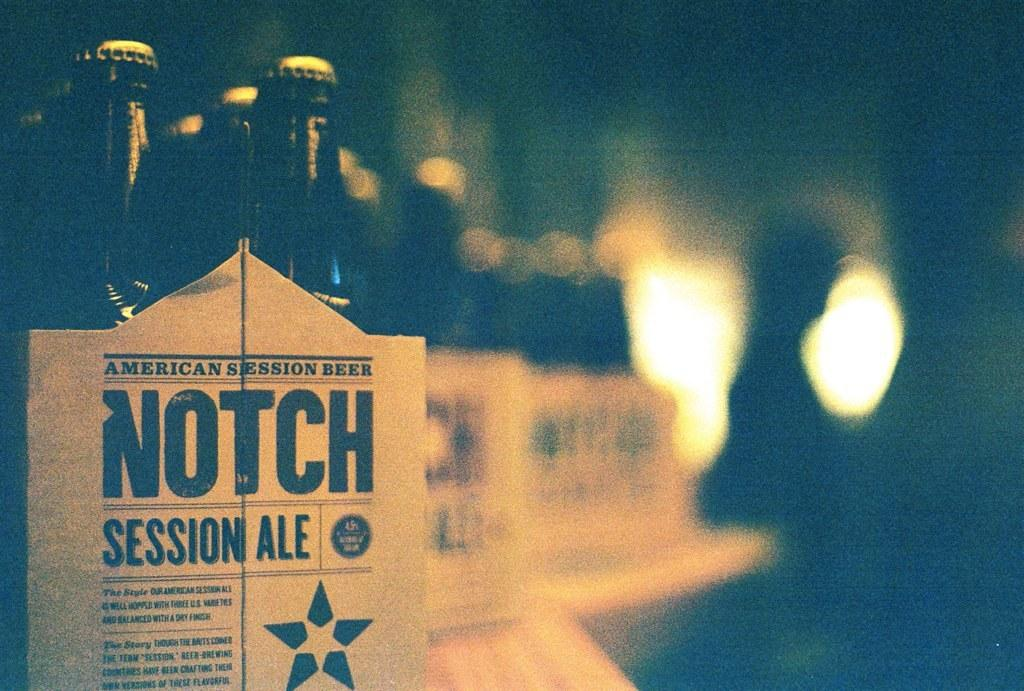What objects are in the foreground of the image? There are bottles in the foreground of the image. How are the bottles arranged or contained? The bottles are in a cardboard box. What can be found on the cardboard box? There is text on the cardboard box. Can you describe the background of the image? The background of the image is blurry. What type of hall is visible in the background of the image? There is no hall visible in the background of the image; it is blurry and does not show any specific location or structure. 